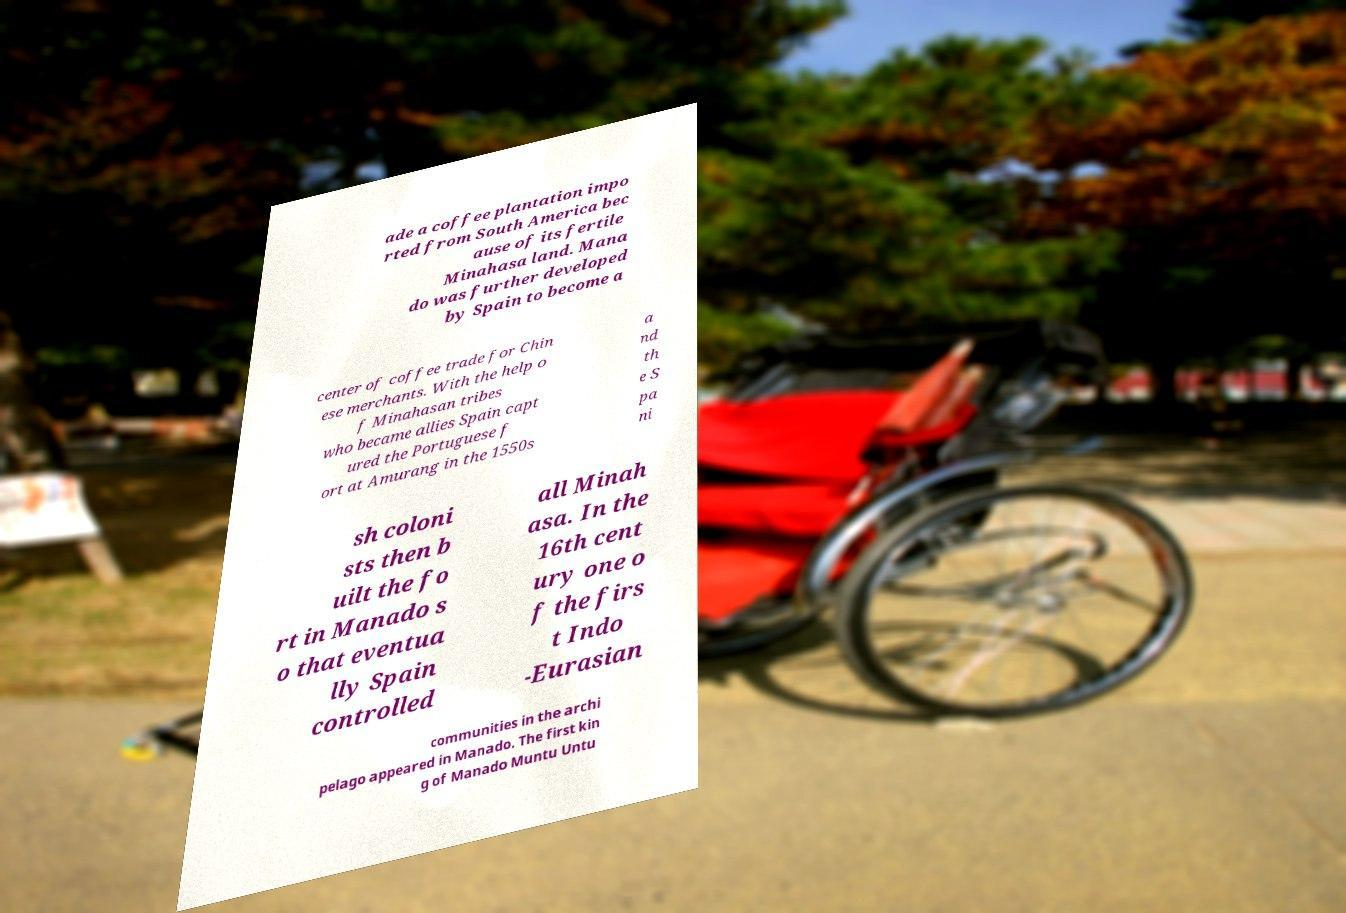Can you read and provide the text displayed in the image?This photo seems to have some interesting text. Can you extract and type it out for me? ade a coffee plantation impo rted from South America bec ause of its fertile Minahasa land. Mana do was further developed by Spain to become a center of coffee trade for Chin ese merchants. With the help o f Minahasan tribes who became allies Spain capt ured the Portuguese f ort at Amurang in the 1550s a nd th e S pa ni sh coloni sts then b uilt the fo rt in Manado s o that eventua lly Spain controlled all Minah asa. In the 16th cent ury one o f the firs t Indo -Eurasian communities in the archi pelago appeared in Manado. The first kin g of Manado Muntu Untu 